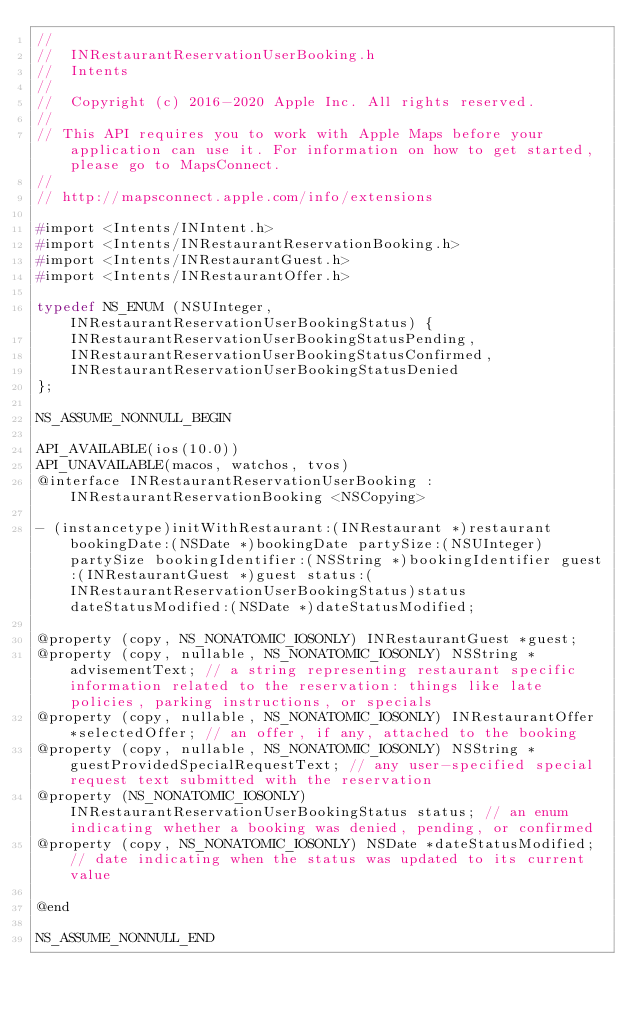<code> <loc_0><loc_0><loc_500><loc_500><_C_>//
//  INRestaurantReservationUserBooking.h
//  Intents
//
//  Copyright (c) 2016-2020 Apple Inc. All rights reserved.
//
// This API requires you to work with Apple Maps before your application can use it. For information on how to get started, please go to MapsConnect.
//
// http://mapsconnect.apple.com/info/extensions

#import <Intents/INIntent.h>
#import <Intents/INRestaurantReservationBooking.h>
#import <Intents/INRestaurantGuest.h>
#import <Intents/INRestaurantOffer.h>

typedef NS_ENUM (NSUInteger, INRestaurantReservationUserBookingStatus) {
    INRestaurantReservationUserBookingStatusPending,
    INRestaurantReservationUserBookingStatusConfirmed,
    INRestaurantReservationUserBookingStatusDenied
};

NS_ASSUME_NONNULL_BEGIN

API_AVAILABLE(ios(10.0))
API_UNAVAILABLE(macos, watchos, tvos)
@interface INRestaurantReservationUserBooking : INRestaurantReservationBooking <NSCopying>

- (instancetype)initWithRestaurant:(INRestaurant *)restaurant bookingDate:(NSDate *)bookingDate partySize:(NSUInteger)partySize bookingIdentifier:(NSString *)bookingIdentifier guest:(INRestaurantGuest *)guest status:(INRestaurantReservationUserBookingStatus)status dateStatusModified:(NSDate *)dateStatusModified;

@property (copy, NS_NONATOMIC_IOSONLY) INRestaurantGuest *guest;
@property (copy, nullable, NS_NONATOMIC_IOSONLY) NSString *advisementText; // a string representing restaurant specific information related to the reservation: things like late policies, parking instructions, or specials
@property (copy, nullable, NS_NONATOMIC_IOSONLY) INRestaurantOffer *selectedOffer; // an offer, if any, attached to the booking
@property (copy, nullable, NS_NONATOMIC_IOSONLY) NSString *guestProvidedSpecialRequestText; // any user-specified special request text submitted with the reservation
@property (NS_NONATOMIC_IOSONLY) INRestaurantReservationUserBookingStatus status; // an enum indicating whether a booking was denied, pending, or confirmed
@property (copy, NS_NONATOMIC_IOSONLY) NSDate *dateStatusModified; // date indicating when the status was updated to its current value

@end

NS_ASSUME_NONNULL_END
</code> 